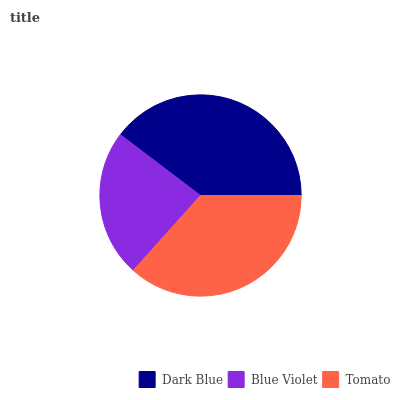Is Blue Violet the minimum?
Answer yes or no. Yes. Is Dark Blue the maximum?
Answer yes or no. Yes. Is Tomato the minimum?
Answer yes or no. No. Is Tomato the maximum?
Answer yes or no. No. Is Tomato greater than Blue Violet?
Answer yes or no. Yes. Is Blue Violet less than Tomato?
Answer yes or no. Yes. Is Blue Violet greater than Tomato?
Answer yes or no. No. Is Tomato less than Blue Violet?
Answer yes or no. No. Is Tomato the high median?
Answer yes or no. Yes. Is Tomato the low median?
Answer yes or no. Yes. Is Dark Blue the high median?
Answer yes or no. No. Is Blue Violet the low median?
Answer yes or no. No. 